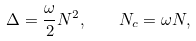<formula> <loc_0><loc_0><loc_500><loc_500>\Delta = \frac { \omega } 2 N ^ { 2 } , \quad N _ { c } = \omega N ,</formula> 